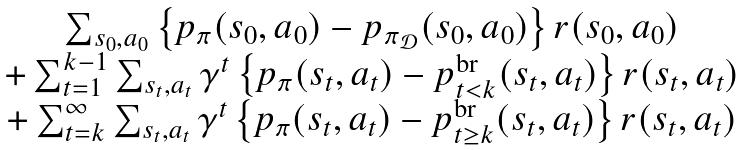Convert formula to latex. <formula><loc_0><loc_0><loc_500><loc_500>\begin{matrix} \sum _ { s _ { 0 } , a _ { 0 } } \left \{ p _ { \pi } ( s _ { 0 } , a _ { 0 } ) - p _ { \pi _ { \mathcal { D } } } ( s _ { 0 } , a _ { 0 } ) \right \} r ( s _ { 0 } , a _ { 0 } ) \\ + \sum _ { t = 1 } ^ { k - 1 } \sum _ { s _ { t } , a _ { t } } \gamma ^ { t } \left \{ p _ { \pi } ( s _ { t } , a _ { t } ) - p _ { t < k } ^ { \text {br} } ( s _ { t } , a _ { t } ) \right \} r ( s _ { t } , a _ { t } ) \\ + \sum _ { t = k } ^ { \infty } \sum _ { s _ { t } , a _ { t } } \gamma ^ { t } \left \{ p _ { \pi } ( s _ { t } , a _ { t } ) - p _ { t \geq k } ^ { \text {br} } ( s _ { t } , a _ { t } ) \right \} r ( s _ { t } , a _ { t } ) \end{matrix}</formula> 